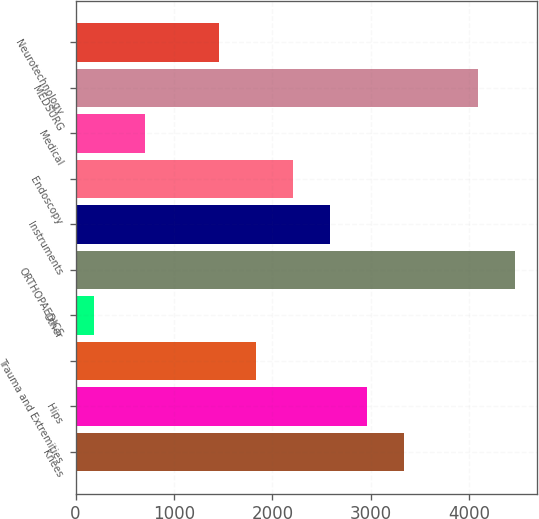<chart> <loc_0><loc_0><loc_500><loc_500><bar_chart><fcel>Knees<fcel>Hips<fcel>Trauma and Extremities<fcel>Other<fcel>ORTHOPAEDICS<fcel>Instruments<fcel>Endoscopy<fcel>Medical<fcel>MEDSURG<fcel>Neurotechnology<nl><fcel>3341.3<fcel>2965.4<fcel>1837.7<fcel>190<fcel>4469<fcel>2589.5<fcel>2213.6<fcel>710<fcel>4093.1<fcel>1461.8<nl></chart> 